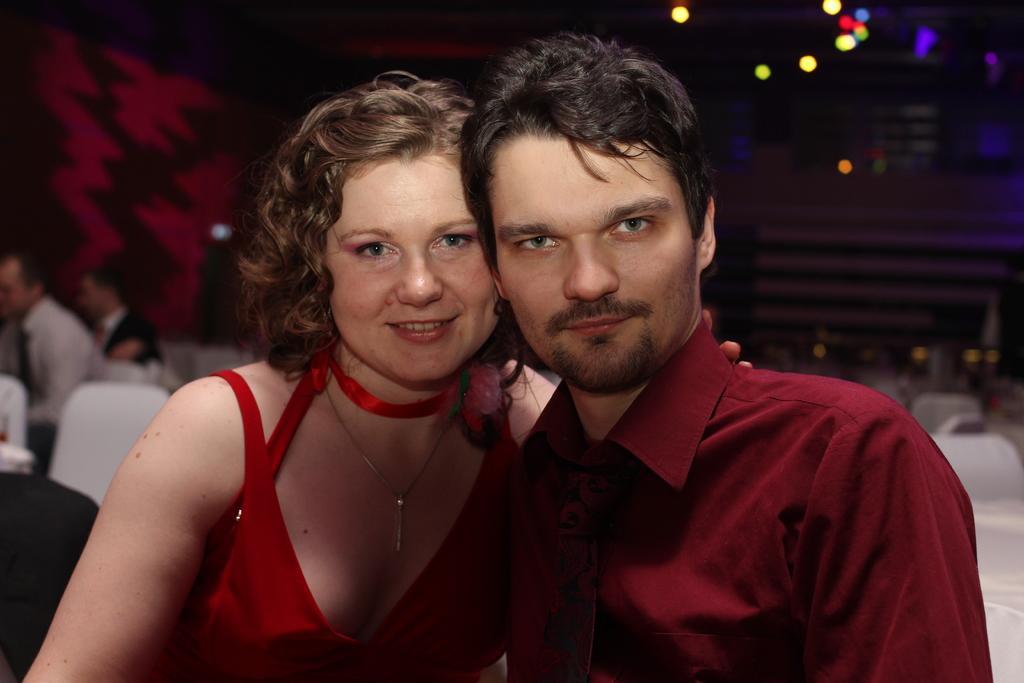How would you summarize this image in a sentence or two? In this picture we can see two people, they are smiling and in the background we can see people, chairs, lights and some objects. 